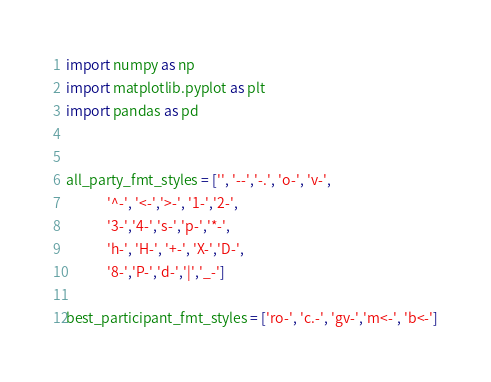Convert code to text. <code><loc_0><loc_0><loc_500><loc_500><_Python_>import numpy as np
import matplotlib.pyplot as plt
import pandas as pd


all_party_fmt_styles = ['', '--','-.', 'o-', 'v-',
			 '^-', '<-','>-', '1-','2-',
			 '3-','4-','s-','p-','*-',
			 'h-', 'H-', '+-', 'X-','D-',
			 '8-','P-','d-','|','_-']

best_participant_fmt_styles = ['ro-', 'c.-', 'gv-','m<-', 'b<-']
</code> 